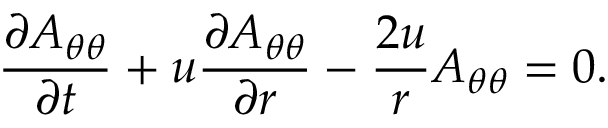Convert formula to latex. <formula><loc_0><loc_0><loc_500><loc_500>\frac { \partial A _ { \theta \theta } } { \partial t } + u \frac { \partial A _ { \theta \theta } } { \partial r } - \frac { 2 u } { r } A _ { \theta \theta } = 0 .</formula> 